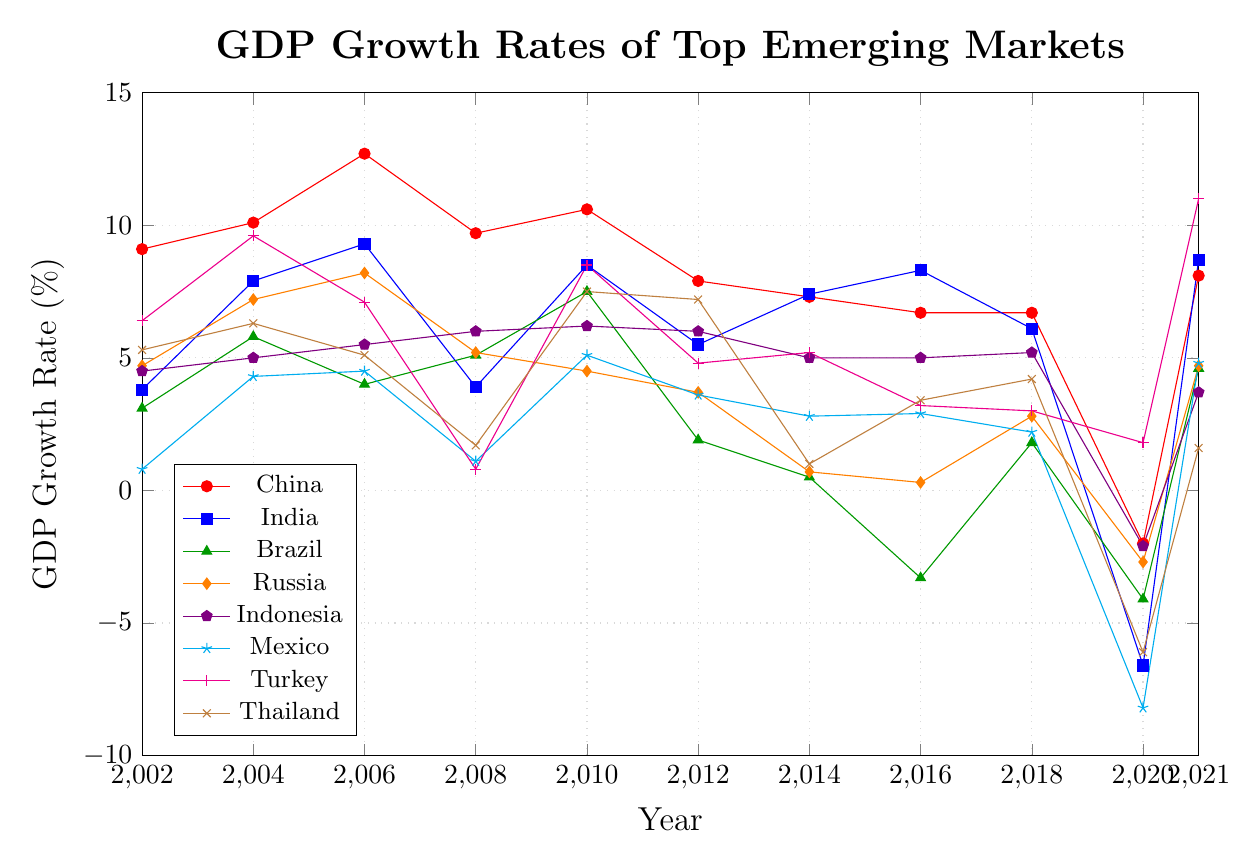What was the GDP growth rate of China in 2020? To find this, look at the data point for China in the year 2020. The line for China intersects with the year 2020 at the GDP growth rate value.
Answer: -2.0% Which country had the highest GDP growth rate in 2021? Check the endpoints of each country's line at the year 2021. Identify the highest point among them.
Answer: Turkey How did the GDP growth rate of Brazil change between 2018 and 2020? Observe the line for Brazil from 2018 to 2020. Record the GDP growth rate values in these years: 1.8% in 2018 to -4.1% in 2020. Subtract the 2020 value from the 2018 value for the change.
Answer: Decreased by 5.9% Who experienced higher GDP growth in 2016, India or Turkey? Find the data points for India and Turkey in 2016. Observe which country's value is higher.
Answer: India What is the average GDP growth rate of Indonesia from 2002 to 2021? Sum the GDP growth rates of Indonesia from 2002 to 2021 and divide by the number of years (11).
Answer: Average: 4.4% Which country had a negative GDP growth rate in 2012? Check the data points for all the countries in 2012 and identify any country with a value below 0.
Answer: None Compare the GDP growth rates of China and Russia in 2021. Which one was higher and by how much? Find the GDP growth rate of China and Russia in 2021. China's rate is 8.1% and Russia's rate is 4.7%. Subtract Russia's value from China's value for the difference.
Answer: China, by 3.4% What color line represents Mexico? Identify the legend entry for Mexico and note the color of the line associated with it.
Answer: Cyan Which country had the most significant drop in GDP growth rate in 2020 compared to 2018? Calculate the difference in GDP growth rates from 2018 to 2020 for each country and determine which reduction is the greatest.
Answer: Mexico Between which years did China experience the most significant decrease in GDP growth rate? Observe the line for China and identify the endpoints of the steepest downward segment.
Answer: Between 2018 and 2020 